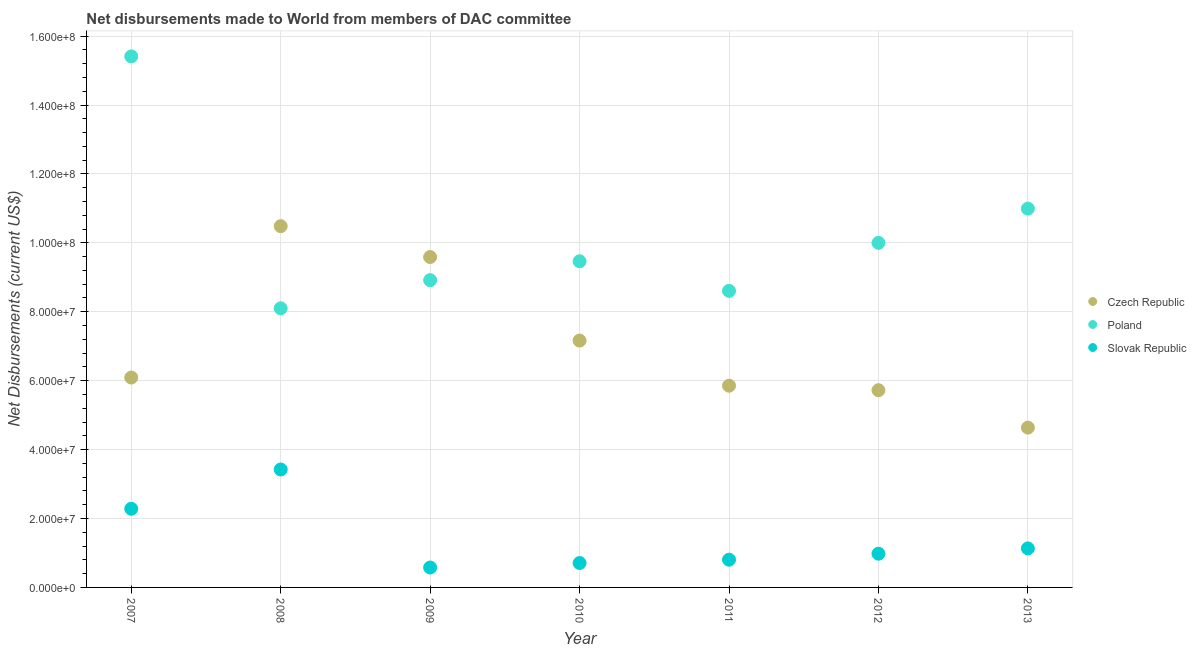How many different coloured dotlines are there?
Your response must be concise. 3. Is the number of dotlines equal to the number of legend labels?
Your answer should be compact. Yes. What is the net disbursements made by slovak republic in 2011?
Offer a terse response. 8.05e+06. Across all years, what is the maximum net disbursements made by slovak republic?
Your answer should be very brief. 3.42e+07. Across all years, what is the minimum net disbursements made by slovak republic?
Give a very brief answer. 5.78e+06. In which year was the net disbursements made by poland maximum?
Give a very brief answer. 2007. What is the total net disbursements made by czech republic in the graph?
Your answer should be compact. 4.95e+08. What is the difference between the net disbursements made by slovak republic in 2012 and that in 2013?
Provide a short and direct response. -1.53e+06. What is the difference between the net disbursements made by czech republic in 2010 and the net disbursements made by slovak republic in 2012?
Your response must be concise. 6.18e+07. What is the average net disbursements made by slovak republic per year?
Keep it short and to the point. 1.42e+07. In the year 2007, what is the difference between the net disbursements made by poland and net disbursements made by czech republic?
Give a very brief answer. 9.32e+07. What is the ratio of the net disbursements made by slovak republic in 2007 to that in 2009?
Your response must be concise. 3.95. Is the net disbursements made by slovak republic in 2008 less than that in 2009?
Make the answer very short. No. What is the difference between the highest and the second highest net disbursements made by czech republic?
Ensure brevity in your answer.  8.96e+06. What is the difference between the highest and the lowest net disbursements made by slovak republic?
Your answer should be compact. 2.84e+07. Is it the case that in every year, the sum of the net disbursements made by czech republic and net disbursements made by poland is greater than the net disbursements made by slovak republic?
Make the answer very short. Yes. Does the net disbursements made by czech republic monotonically increase over the years?
Make the answer very short. No. How many dotlines are there?
Your answer should be compact. 3. How many years are there in the graph?
Offer a terse response. 7. What is the title of the graph?
Provide a short and direct response. Net disbursements made to World from members of DAC committee. Does "Ores and metals" appear as one of the legend labels in the graph?
Make the answer very short. No. What is the label or title of the Y-axis?
Provide a succinct answer. Net Disbursements (current US$). What is the Net Disbursements (current US$) of Czech Republic in 2007?
Offer a terse response. 6.09e+07. What is the Net Disbursements (current US$) in Poland in 2007?
Give a very brief answer. 1.54e+08. What is the Net Disbursements (current US$) of Slovak Republic in 2007?
Your response must be concise. 2.28e+07. What is the Net Disbursements (current US$) of Czech Republic in 2008?
Provide a short and direct response. 1.05e+08. What is the Net Disbursements (current US$) in Poland in 2008?
Offer a very short reply. 8.10e+07. What is the Net Disbursements (current US$) of Slovak Republic in 2008?
Keep it short and to the point. 3.42e+07. What is the Net Disbursements (current US$) of Czech Republic in 2009?
Offer a very short reply. 9.59e+07. What is the Net Disbursements (current US$) of Poland in 2009?
Ensure brevity in your answer.  8.92e+07. What is the Net Disbursements (current US$) of Slovak Republic in 2009?
Offer a very short reply. 5.78e+06. What is the Net Disbursements (current US$) in Czech Republic in 2010?
Provide a succinct answer. 7.16e+07. What is the Net Disbursements (current US$) in Poland in 2010?
Your answer should be very brief. 9.46e+07. What is the Net Disbursements (current US$) of Slovak Republic in 2010?
Make the answer very short. 7.08e+06. What is the Net Disbursements (current US$) in Czech Republic in 2011?
Provide a succinct answer. 5.85e+07. What is the Net Disbursements (current US$) in Poland in 2011?
Offer a terse response. 8.61e+07. What is the Net Disbursements (current US$) of Slovak Republic in 2011?
Provide a succinct answer. 8.05e+06. What is the Net Disbursements (current US$) of Czech Republic in 2012?
Offer a terse response. 5.72e+07. What is the Net Disbursements (current US$) of Poland in 2012?
Keep it short and to the point. 1.00e+08. What is the Net Disbursements (current US$) in Slovak Republic in 2012?
Provide a short and direct response. 9.79e+06. What is the Net Disbursements (current US$) of Czech Republic in 2013?
Offer a very short reply. 4.64e+07. What is the Net Disbursements (current US$) in Poland in 2013?
Your answer should be compact. 1.10e+08. What is the Net Disbursements (current US$) of Slovak Republic in 2013?
Your answer should be very brief. 1.13e+07. Across all years, what is the maximum Net Disbursements (current US$) of Czech Republic?
Give a very brief answer. 1.05e+08. Across all years, what is the maximum Net Disbursements (current US$) of Poland?
Give a very brief answer. 1.54e+08. Across all years, what is the maximum Net Disbursements (current US$) in Slovak Republic?
Ensure brevity in your answer.  3.42e+07. Across all years, what is the minimum Net Disbursements (current US$) in Czech Republic?
Your answer should be very brief. 4.64e+07. Across all years, what is the minimum Net Disbursements (current US$) in Poland?
Keep it short and to the point. 8.10e+07. Across all years, what is the minimum Net Disbursements (current US$) of Slovak Republic?
Provide a succinct answer. 5.78e+06. What is the total Net Disbursements (current US$) of Czech Republic in the graph?
Keep it short and to the point. 4.95e+08. What is the total Net Disbursements (current US$) in Poland in the graph?
Offer a very short reply. 7.15e+08. What is the total Net Disbursements (current US$) of Slovak Republic in the graph?
Your response must be concise. 9.91e+07. What is the difference between the Net Disbursements (current US$) of Czech Republic in 2007 and that in 2008?
Provide a short and direct response. -4.39e+07. What is the difference between the Net Disbursements (current US$) in Poland in 2007 and that in 2008?
Ensure brevity in your answer.  7.31e+07. What is the difference between the Net Disbursements (current US$) of Slovak Republic in 2007 and that in 2008?
Make the answer very short. -1.14e+07. What is the difference between the Net Disbursements (current US$) in Czech Republic in 2007 and that in 2009?
Ensure brevity in your answer.  -3.50e+07. What is the difference between the Net Disbursements (current US$) in Poland in 2007 and that in 2009?
Provide a short and direct response. 6.49e+07. What is the difference between the Net Disbursements (current US$) in Slovak Republic in 2007 and that in 2009?
Provide a succinct answer. 1.70e+07. What is the difference between the Net Disbursements (current US$) of Czech Republic in 2007 and that in 2010?
Keep it short and to the point. -1.07e+07. What is the difference between the Net Disbursements (current US$) of Poland in 2007 and that in 2010?
Offer a terse response. 5.95e+07. What is the difference between the Net Disbursements (current US$) in Slovak Republic in 2007 and that in 2010?
Keep it short and to the point. 1.58e+07. What is the difference between the Net Disbursements (current US$) in Czech Republic in 2007 and that in 2011?
Make the answer very short. 2.37e+06. What is the difference between the Net Disbursements (current US$) of Poland in 2007 and that in 2011?
Give a very brief answer. 6.80e+07. What is the difference between the Net Disbursements (current US$) of Slovak Republic in 2007 and that in 2011?
Keep it short and to the point. 1.48e+07. What is the difference between the Net Disbursements (current US$) in Czech Republic in 2007 and that in 2012?
Provide a short and direct response. 3.67e+06. What is the difference between the Net Disbursements (current US$) of Poland in 2007 and that in 2012?
Give a very brief answer. 5.41e+07. What is the difference between the Net Disbursements (current US$) in Slovak Republic in 2007 and that in 2012?
Offer a terse response. 1.30e+07. What is the difference between the Net Disbursements (current US$) of Czech Republic in 2007 and that in 2013?
Offer a very short reply. 1.45e+07. What is the difference between the Net Disbursements (current US$) in Poland in 2007 and that in 2013?
Give a very brief answer. 4.42e+07. What is the difference between the Net Disbursements (current US$) in Slovak Republic in 2007 and that in 2013?
Provide a short and direct response. 1.15e+07. What is the difference between the Net Disbursements (current US$) in Czech Republic in 2008 and that in 2009?
Your answer should be very brief. 8.96e+06. What is the difference between the Net Disbursements (current US$) in Poland in 2008 and that in 2009?
Your answer should be compact. -8.17e+06. What is the difference between the Net Disbursements (current US$) in Slovak Republic in 2008 and that in 2009?
Your answer should be very brief. 2.84e+07. What is the difference between the Net Disbursements (current US$) in Czech Republic in 2008 and that in 2010?
Keep it short and to the point. 3.32e+07. What is the difference between the Net Disbursements (current US$) in Poland in 2008 and that in 2010?
Your response must be concise. -1.36e+07. What is the difference between the Net Disbursements (current US$) in Slovak Republic in 2008 and that in 2010?
Offer a terse response. 2.72e+07. What is the difference between the Net Disbursements (current US$) in Czech Republic in 2008 and that in 2011?
Give a very brief answer. 4.63e+07. What is the difference between the Net Disbursements (current US$) of Poland in 2008 and that in 2011?
Your answer should be very brief. -5.07e+06. What is the difference between the Net Disbursements (current US$) in Slovak Republic in 2008 and that in 2011?
Provide a succinct answer. 2.62e+07. What is the difference between the Net Disbursements (current US$) of Czech Republic in 2008 and that in 2012?
Make the answer very short. 4.76e+07. What is the difference between the Net Disbursements (current US$) in Poland in 2008 and that in 2012?
Ensure brevity in your answer.  -1.90e+07. What is the difference between the Net Disbursements (current US$) of Slovak Republic in 2008 and that in 2012?
Your answer should be very brief. 2.44e+07. What is the difference between the Net Disbursements (current US$) of Czech Republic in 2008 and that in 2013?
Your answer should be very brief. 5.85e+07. What is the difference between the Net Disbursements (current US$) in Poland in 2008 and that in 2013?
Your response must be concise. -2.89e+07. What is the difference between the Net Disbursements (current US$) in Slovak Republic in 2008 and that in 2013?
Ensure brevity in your answer.  2.29e+07. What is the difference between the Net Disbursements (current US$) in Czech Republic in 2009 and that in 2010?
Ensure brevity in your answer.  2.42e+07. What is the difference between the Net Disbursements (current US$) in Poland in 2009 and that in 2010?
Ensure brevity in your answer.  -5.48e+06. What is the difference between the Net Disbursements (current US$) in Slovak Republic in 2009 and that in 2010?
Provide a succinct answer. -1.30e+06. What is the difference between the Net Disbursements (current US$) of Czech Republic in 2009 and that in 2011?
Your answer should be compact. 3.73e+07. What is the difference between the Net Disbursements (current US$) in Poland in 2009 and that in 2011?
Provide a short and direct response. 3.10e+06. What is the difference between the Net Disbursements (current US$) in Slovak Republic in 2009 and that in 2011?
Your answer should be compact. -2.27e+06. What is the difference between the Net Disbursements (current US$) in Czech Republic in 2009 and that in 2012?
Keep it short and to the point. 3.86e+07. What is the difference between the Net Disbursements (current US$) of Poland in 2009 and that in 2012?
Make the answer very short. -1.08e+07. What is the difference between the Net Disbursements (current US$) of Slovak Republic in 2009 and that in 2012?
Ensure brevity in your answer.  -4.01e+06. What is the difference between the Net Disbursements (current US$) in Czech Republic in 2009 and that in 2013?
Give a very brief answer. 4.95e+07. What is the difference between the Net Disbursements (current US$) in Poland in 2009 and that in 2013?
Give a very brief answer. -2.08e+07. What is the difference between the Net Disbursements (current US$) in Slovak Republic in 2009 and that in 2013?
Your response must be concise. -5.54e+06. What is the difference between the Net Disbursements (current US$) in Czech Republic in 2010 and that in 2011?
Your response must be concise. 1.31e+07. What is the difference between the Net Disbursements (current US$) of Poland in 2010 and that in 2011?
Ensure brevity in your answer.  8.58e+06. What is the difference between the Net Disbursements (current US$) in Slovak Republic in 2010 and that in 2011?
Provide a short and direct response. -9.70e+05. What is the difference between the Net Disbursements (current US$) in Czech Republic in 2010 and that in 2012?
Provide a short and direct response. 1.44e+07. What is the difference between the Net Disbursements (current US$) in Poland in 2010 and that in 2012?
Make the answer very short. -5.34e+06. What is the difference between the Net Disbursements (current US$) in Slovak Republic in 2010 and that in 2012?
Provide a short and direct response. -2.71e+06. What is the difference between the Net Disbursements (current US$) in Czech Republic in 2010 and that in 2013?
Offer a very short reply. 2.53e+07. What is the difference between the Net Disbursements (current US$) of Poland in 2010 and that in 2013?
Ensure brevity in your answer.  -1.53e+07. What is the difference between the Net Disbursements (current US$) in Slovak Republic in 2010 and that in 2013?
Your response must be concise. -4.24e+06. What is the difference between the Net Disbursements (current US$) in Czech Republic in 2011 and that in 2012?
Your answer should be compact. 1.30e+06. What is the difference between the Net Disbursements (current US$) of Poland in 2011 and that in 2012?
Make the answer very short. -1.39e+07. What is the difference between the Net Disbursements (current US$) of Slovak Republic in 2011 and that in 2012?
Your answer should be compact. -1.74e+06. What is the difference between the Net Disbursements (current US$) in Czech Republic in 2011 and that in 2013?
Make the answer very short. 1.22e+07. What is the difference between the Net Disbursements (current US$) of Poland in 2011 and that in 2013?
Provide a succinct answer. -2.39e+07. What is the difference between the Net Disbursements (current US$) in Slovak Republic in 2011 and that in 2013?
Your answer should be compact. -3.27e+06. What is the difference between the Net Disbursements (current US$) in Czech Republic in 2012 and that in 2013?
Your answer should be very brief. 1.09e+07. What is the difference between the Net Disbursements (current US$) of Poland in 2012 and that in 2013?
Provide a succinct answer. -9.94e+06. What is the difference between the Net Disbursements (current US$) in Slovak Republic in 2012 and that in 2013?
Your answer should be very brief. -1.53e+06. What is the difference between the Net Disbursements (current US$) in Czech Republic in 2007 and the Net Disbursements (current US$) in Poland in 2008?
Give a very brief answer. -2.01e+07. What is the difference between the Net Disbursements (current US$) of Czech Republic in 2007 and the Net Disbursements (current US$) of Slovak Republic in 2008?
Make the answer very short. 2.67e+07. What is the difference between the Net Disbursements (current US$) of Poland in 2007 and the Net Disbursements (current US$) of Slovak Republic in 2008?
Offer a very short reply. 1.20e+08. What is the difference between the Net Disbursements (current US$) of Czech Republic in 2007 and the Net Disbursements (current US$) of Poland in 2009?
Make the answer very short. -2.83e+07. What is the difference between the Net Disbursements (current US$) of Czech Republic in 2007 and the Net Disbursements (current US$) of Slovak Republic in 2009?
Your answer should be very brief. 5.51e+07. What is the difference between the Net Disbursements (current US$) of Poland in 2007 and the Net Disbursements (current US$) of Slovak Republic in 2009?
Ensure brevity in your answer.  1.48e+08. What is the difference between the Net Disbursements (current US$) of Czech Republic in 2007 and the Net Disbursements (current US$) of Poland in 2010?
Give a very brief answer. -3.37e+07. What is the difference between the Net Disbursements (current US$) of Czech Republic in 2007 and the Net Disbursements (current US$) of Slovak Republic in 2010?
Your answer should be very brief. 5.38e+07. What is the difference between the Net Disbursements (current US$) of Poland in 2007 and the Net Disbursements (current US$) of Slovak Republic in 2010?
Give a very brief answer. 1.47e+08. What is the difference between the Net Disbursements (current US$) of Czech Republic in 2007 and the Net Disbursements (current US$) of Poland in 2011?
Ensure brevity in your answer.  -2.52e+07. What is the difference between the Net Disbursements (current US$) of Czech Republic in 2007 and the Net Disbursements (current US$) of Slovak Republic in 2011?
Ensure brevity in your answer.  5.29e+07. What is the difference between the Net Disbursements (current US$) in Poland in 2007 and the Net Disbursements (current US$) in Slovak Republic in 2011?
Your answer should be compact. 1.46e+08. What is the difference between the Net Disbursements (current US$) in Czech Republic in 2007 and the Net Disbursements (current US$) in Poland in 2012?
Provide a succinct answer. -3.91e+07. What is the difference between the Net Disbursements (current US$) of Czech Republic in 2007 and the Net Disbursements (current US$) of Slovak Republic in 2012?
Offer a terse response. 5.11e+07. What is the difference between the Net Disbursements (current US$) in Poland in 2007 and the Net Disbursements (current US$) in Slovak Republic in 2012?
Ensure brevity in your answer.  1.44e+08. What is the difference between the Net Disbursements (current US$) in Czech Republic in 2007 and the Net Disbursements (current US$) in Poland in 2013?
Give a very brief answer. -4.90e+07. What is the difference between the Net Disbursements (current US$) in Czech Republic in 2007 and the Net Disbursements (current US$) in Slovak Republic in 2013?
Offer a terse response. 4.96e+07. What is the difference between the Net Disbursements (current US$) of Poland in 2007 and the Net Disbursements (current US$) of Slovak Republic in 2013?
Give a very brief answer. 1.43e+08. What is the difference between the Net Disbursements (current US$) of Czech Republic in 2008 and the Net Disbursements (current US$) of Poland in 2009?
Your response must be concise. 1.57e+07. What is the difference between the Net Disbursements (current US$) of Czech Republic in 2008 and the Net Disbursements (current US$) of Slovak Republic in 2009?
Keep it short and to the point. 9.91e+07. What is the difference between the Net Disbursements (current US$) of Poland in 2008 and the Net Disbursements (current US$) of Slovak Republic in 2009?
Make the answer very short. 7.52e+07. What is the difference between the Net Disbursements (current US$) of Czech Republic in 2008 and the Net Disbursements (current US$) of Poland in 2010?
Provide a short and direct response. 1.02e+07. What is the difference between the Net Disbursements (current US$) of Czech Republic in 2008 and the Net Disbursements (current US$) of Slovak Republic in 2010?
Offer a terse response. 9.78e+07. What is the difference between the Net Disbursements (current US$) in Poland in 2008 and the Net Disbursements (current US$) in Slovak Republic in 2010?
Your response must be concise. 7.39e+07. What is the difference between the Net Disbursements (current US$) in Czech Republic in 2008 and the Net Disbursements (current US$) in Poland in 2011?
Your response must be concise. 1.88e+07. What is the difference between the Net Disbursements (current US$) of Czech Republic in 2008 and the Net Disbursements (current US$) of Slovak Republic in 2011?
Keep it short and to the point. 9.68e+07. What is the difference between the Net Disbursements (current US$) of Poland in 2008 and the Net Disbursements (current US$) of Slovak Republic in 2011?
Make the answer very short. 7.30e+07. What is the difference between the Net Disbursements (current US$) of Czech Republic in 2008 and the Net Disbursements (current US$) of Poland in 2012?
Your answer should be compact. 4.85e+06. What is the difference between the Net Disbursements (current US$) in Czech Republic in 2008 and the Net Disbursements (current US$) in Slovak Republic in 2012?
Your answer should be compact. 9.50e+07. What is the difference between the Net Disbursements (current US$) of Poland in 2008 and the Net Disbursements (current US$) of Slovak Republic in 2012?
Provide a succinct answer. 7.12e+07. What is the difference between the Net Disbursements (current US$) of Czech Republic in 2008 and the Net Disbursements (current US$) of Poland in 2013?
Your answer should be very brief. -5.09e+06. What is the difference between the Net Disbursements (current US$) in Czech Republic in 2008 and the Net Disbursements (current US$) in Slovak Republic in 2013?
Offer a very short reply. 9.35e+07. What is the difference between the Net Disbursements (current US$) of Poland in 2008 and the Net Disbursements (current US$) of Slovak Republic in 2013?
Give a very brief answer. 6.97e+07. What is the difference between the Net Disbursements (current US$) in Czech Republic in 2009 and the Net Disbursements (current US$) in Poland in 2010?
Keep it short and to the point. 1.23e+06. What is the difference between the Net Disbursements (current US$) in Czech Republic in 2009 and the Net Disbursements (current US$) in Slovak Republic in 2010?
Provide a short and direct response. 8.88e+07. What is the difference between the Net Disbursements (current US$) in Poland in 2009 and the Net Disbursements (current US$) in Slovak Republic in 2010?
Give a very brief answer. 8.21e+07. What is the difference between the Net Disbursements (current US$) in Czech Republic in 2009 and the Net Disbursements (current US$) in Poland in 2011?
Provide a short and direct response. 9.81e+06. What is the difference between the Net Disbursements (current US$) of Czech Republic in 2009 and the Net Disbursements (current US$) of Slovak Republic in 2011?
Ensure brevity in your answer.  8.78e+07. What is the difference between the Net Disbursements (current US$) of Poland in 2009 and the Net Disbursements (current US$) of Slovak Republic in 2011?
Ensure brevity in your answer.  8.11e+07. What is the difference between the Net Disbursements (current US$) of Czech Republic in 2009 and the Net Disbursements (current US$) of Poland in 2012?
Offer a very short reply. -4.11e+06. What is the difference between the Net Disbursements (current US$) of Czech Republic in 2009 and the Net Disbursements (current US$) of Slovak Republic in 2012?
Make the answer very short. 8.61e+07. What is the difference between the Net Disbursements (current US$) in Poland in 2009 and the Net Disbursements (current US$) in Slovak Republic in 2012?
Provide a short and direct response. 7.94e+07. What is the difference between the Net Disbursements (current US$) in Czech Republic in 2009 and the Net Disbursements (current US$) in Poland in 2013?
Provide a succinct answer. -1.40e+07. What is the difference between the Net Disbursements (current US$) of Czech Republic in 2009 and the Net Disbursements (current US$) of Slovak Republic in 2013?
Give a very brief answer. 8.46e+07. What is the difference between the Net Disbursements (current US$) in Poland in 2009 and the Net Disbursements (current US$) in Slovak Republic in 2013?
Your answer should be compact. 7.78e+07. What is the difference between the Net Disbursements (current US$) in Czech Republic in 2010 and the Net Disbursements (current US$) in Poland in 2011?
Provide a succinct answer. -1.44e+07. What is the difference between the Net Disbursements (current US$) of Czech Republic in 2010 and the Net Disbursements (current US$) of Slovak Republic in 2011?
Offer a very short reply. 6.36e+07. What is the difference between the Net Disbursements (current US$) of Poland in 2010 and the Net Disbursements (current US$) of Slovak Republic in 2011?
Offer a terse response. 8.66e+07. What is the difference between the Net Disbursements (current US$) in Czech Republic in 2010 and the Net Disbursements (current US$) in Poland in 2012?
Keep it short and to the point. -2.84e+07. What is the difference between the Net Disbursements (current US$) of Czech Republic in 2010 and the Net Disbursements (current US$) of Slovak Republic in 2012?
Your answer should be compact. 6.18e+07. What is the difference between the Net Disbursements (current US$) of Poland in 2010 and the Net Disbursements (current US$) of Slovak Republic in 2012?
Your answer should be very brief. 8.49e+07. What is the difference between the Net Disbursements (current US$) of Czech Republic in 2010 and the Net Disbursements (current US$) of Poland in 2013?
Keep it short and to the point. -3.83e+07. What is the difference between the Net Disbursements (current US$) in Czech Republic in 2010 and the Net Disbursements (current US$) in Slovak Republic in 2013?
Provide a short and direct response. 6.03e+07. What is the difference between the Net Disbursements (current US$) in Poland in 2010 and the Net Disbursements (current US$) in Slovak Republic in 2013?
Offer a terse response. 8.33e+07. What is the difference between the Net Disbursements (current US$) of Czech Republic in 2011 and the Net Disbursements (current US$) of Poland in 2012?
Your response must be concise. -4.14e+07. What is the difference between the Net Disbursements (current US$) in Czech Republic in 2011 and the Net Disbursements (current US$) in Slovak Republic in 2012?
Make the answer very short. 4.88e+07. What is the difference between the Net Disbursements (current US$) of Poland in 2011 and the Net Disbursements (current US$) of Slovak Republic in 2012?
Keep it short and to the point. 7.63e+07. What is the difference between the Net Disbursements (current US$) in Czech Republic in 2011 and the Net Disbursements (current US$) in Poland in 2013?
Give a very brief answer. -5.14e+07. What is the difference between the Net Disbursements (current US$) in Czech Republic in 2011 and the Net Disbursements (current US$) in Slovak Republic in 2013?
Give a very brief answer. 4.72e+07. What is the difference between the Net Disbursements (current US$) of Poland in 2011 and the Net Disbursements (current US$) of Slovak Republic in 2013?
Ensure brevity in your answer.  7.48e+07. What is the difference between the Net Disbursements (current US$) of Czech Republic in 2012 and the Net Disbursements (current US$) of Poland in 2013?
Provide a short and direct response. -5.27e+07. What is the difference between the Net Disbursements (current US$) of Czech Republic in 2012 and the Net Disbursements (current US$) of Slovak Republic in 2013?
Provide a succinct answer. 4.59e+07. What is the difference between the Net Disbursements (current US$) of Poland in 2012 and the Net Disbursements (current US$) of Slovak Republic in 2013?
Offer a terse response. 8.87e+07. What is the average Net Disbursements (current US$) of Czech Republic per year?
Make the answer very short. 7.08e+07. What is the average Net Disbursements (current US$) in Poland per year?
Provide a succinct answer. 1.02e+08. What is the average Net Disbursements (current US$) in Slovak Republic per year?
Ensure brevity in your answer.  1.42e+07. In the year 2007, what is the difference between the Net Disbursements (current US$) of Czech Republic and Net Disbursements (current US$) of Poland?
Your answer should be compact. -9.32e+07. In the year 2007, what is the difference between the Net Disbursements (current US$) in Czech Republic and Net Disbursements (current US$) in Slovak Republic?
Your answer should be compact. 3.81e+07. In the year 2007, what is the difference between the Net Disbursements (current US$) of Poland and Net Disbursements (current US$) of Slovak Republic?
Your answer should be compact. 1.31e+08. In the year 2008, what is the difference between the Net Disbursements (current US$) in Czech Republic and Net Disbursements (current US$) in Poland?
Provide a short and direct response. 2.38e+07. In the year 2008, what is the difference between the Net Disbursements (current US$) in Czech Republic and Net Disbursements (current US$) in Slovak Republic?
Keep it short and to the point. 7.06e+07. In the year 2008, what is the difference between the Net Disbursements (current US$) in Poland and Net Disbursements (current US$) in Slovak Republic?
Offer a very short reply. 4.68e+07. In the year 2009, what is the difference between the Net Disbursements (current US$) of Czech Republic and Net Disbursements (current US$) of Poland?
Your answer should be compact. 6.71e+06. In the year 2009, what is the difference between the Net Disbursements (current US$) of Czech Republic and Net Disbursements (current US$) of Slovak Republic?
Your answer should be very brief. 9.01e+07. In the year 2009, what is the difference between the Net Disbursements (current US$) in Poland and Net Disbursements (current US$) in Slovak Republic?
Offer a terse response. 8.34e+07. In the year 2010, what is the difference between the Net Disbursements (current US$) of Czech Republic and Net Disbursements (current US$) of Poland?
Provide a succinct answer. -2.30e+07. In the year 2010, what is the difference between the Net Disbursements (current US$) in Czech Republic and Net Disbursements (current US$) in Slovak Republic?
Provide a succinct answer. 6.46e+07. In the year 2010, what is the difference between the Net Disbursements (current US$) of Poland and Net Disbursements (current US$) of Slovak Republic?
Give a very brief answer. 8.76e+07. In the year 2011, what is the difference between the Net Disbursements (current US$) in Czech Republic and Net Disbursements (current US$) in Poland?
Your answer should be compact. -2.75e+07. In the year 2011, what is the difference between the Net Disbursements (current US$) in Czech Republic and Net Disbursements (current US$) in Slovak Republic?
Keep it short and to the point. 5.05e+07. In the year 2011, what is the difference between the Net Disbursements (current US$) of Poland and Net Disbursements (current US$) of Slovak Republic?
Your answer should be compact. 7.80e+07. In the year 2012, what is the difference between the Net Disbursements (current US$) in Czech Republic and Net Disbursements (current US$) in Poland?
Offer a terse response. -4.28e+07. In the year 2012, what is the difference between the Net Disbursements (current US$) of Czech Republic and Net Disbursements (current US$) of Slovak Republic?
Provide a short and direct response. 4.74e+07. In the year 2012, what is the difference between the Net Disbursements (current US$) in Poland and Net Disbursements (current US$) in Slovak Republic?
Ensure brevity in your answer.  9.02e+07. In the year 2013, what is the difference between the Net Disbursements (current US$) in Czech Republic and Net Disbursements (current US$) in Poland?
Offer a very short reply. -6.36e+07. In the year 2013, what is the difference between the Net Disbursements (current US$) of Czech Republic and Net Disbursements (current US$) of Slovak Republic?
Your answer should be compact. 3.51e+07. In the year 2013, what is the difference between the Net Disbursements (current US$) in Poland and Net Disbursements (current US$) in Slovak Republic?
Keep it short and to the point. 9.86e+07. What is the ratio of the Net Disbursements (current US$) of Czech Republic in 2007 to that in 2008?
Your answer should be compact. 0.58. What is the ratio of the Net Disbursements (current US$) in Poland in 2007 to that in 2008?
Give a very brief answer. 1.9. What is the ratio of the Net Disbursements (current US$) of Slovak Republic in 2007 to that in 2008?
Offer a terse response. 0.67. What is the ratio of the Net Disbursements (current US$) in Czech Republic in 2007 to that in 2009?
Make the answer very short. 0.64. What is the ratio of the Net Disbursements (current US$) of Poland in 2007 to that in 2009?
Ensure brevity in your answer.  1.73. What is the ratio of the Net Disbursements (current US$) in Slovak Republic in 2007 to that in 2009?
Make the answer very short. 3.95. What is the ratio of the Net Disbursements (current US$) in Czech Republic in 2007 to that in 2010?
Make the answer very short. 0.85. What is the ratio of the Net Disbursements (current US$) in Poland in 2007 to that in 2010?
Give a very brief answer. 1.63. What is the ratio of the Net Disbursements (current US$) of Slovak Republic in 2007 to that in 2010?
Your answer should be very brief. 3.22. What is the ratio of the Net Disbursements (current US$) of Czech Republic in 2007 to that in 2011?
Offer a very short reply. 1.04. What is the ratio of the Net Disbursements (current US$) of Poland in 2007 to that in 2011?
Keep it short and to the point. 1.79. What is the ratio of the Net Disbursements (current US$) in Slovak Republic in 2007 to that in 2011?
Your answer should be compact. 2.84. What is the ratio of the Net Disbursements (current US$) of Czech Republic in 2007 to that in 2012?
Provide a succinct answer. 1.06. What is the ratio of the Net Disbursements (current US$) of Poland in 2007 to that in 2012?
Provide a succinct answer. 1.54. What is the ratio of the Net Disbursements (current US$) in Slovak Republic in 2007 to that in 2012?
Provide a short and direct response. 2.33. What is the ratio of the Net Disbursements (current US$) of Czech Republic in 2007 to that in 2013?
Provide a short and direct response. 1.31. What is the ratio of the Net Disbursements (current US$) in Poland in 2007 to that in 2013?
Make the answer very short. 1.4. What is the ratio of the Net Disbursements (current US$) in Slovak Republic in 2007 to that in 2013?
Your answer should be very brief. 2.02. What is the ratio of the Net Disbursements (current US$) of Czech Republic in 2008 to that in 2009?
Your answer should be very brief. 1.09. What is the ratio of the Net Disbursements (current US$) in Poland in 2008 to that in 2009?
Provide a succinct answer. 0.91. What is the ratio of the Net Disbursements (current US$) in Slovak Republic in 2008 to that in 2009?
Make the answer very short. 5.92. What is the ratio of the Net Disbursements (current US$) in Czech Republic in 2008 to that in 2010?
Keep it short and to the point. 1.46. What is the ratio of the Net Disbursements (current US$) in Poland in 2008 to that in 2010?
Provide a succinct answer. 0.86. What is the ratio of the Net Disbursements (current US$) in Slovak Republic in 2008 to that in 2010?
Your response must be concise. 4.83. What is the ratio of the Net Disbursements (current US$) in Czech Republic in 2008 to that in 2011?
Your answer should be compact. 1.79. What is the ratio of the Net Disbursements (current US$) in Poland in 2008 to that in 2011?
Your response must be concise. 0.94. What is the ratio of the Net Disbursements (current US$) in Slovak Republic in 2008 to that in 2011?
Make the answer very short. 4.25. What is the ratio of the Net Disbursements (current US$) of Czech Republic in 2008 to that in 2012?
Keep it short and to the point. 1.83. What is the ratio of the Net Disbursements (current US$) in Poland in 2008 to that in 2012?
Ensure brevity in your answer.  0.81. What is the ratio of the Net Disbursements (current US$) of Slovak Republic in 2008 to that in 2012?
Make the answer very short. 3.5. What is the ratio of the Net Disbursements (current US$) in Czech Republic in 2008 to that in 2013?
Make the answer very short. 2.26. What is the ratio of the Net Disbursements (current US$) in Poland in 2008 to that in 2013?
Your answer should be very brief. 0.74. What is the ratio of the Net Disbursements (current US$) of Slovak Republic in 2008 to that in 2013?
Offer a very short reply. 3.02. What is the ratio of the Net Disbursements (current US$) of Czech Republic in 2009 to that in 2010?
Offer a terse response. 1.34. What is the ratio of the Net Disbursements (current US$) in Poland in 2009 to that in 2010?
Your answer should be very brief. 0.94. What is the ratio of the Net Disbursements (current US$) in Slovak Republic in 2009 to that in 2010?
Provide a succinct answer. 0.82. What is the ratio of the Net Disbursements (current US$) in Czech Republic in 2009 to that in 2011?
Ensure brevity in your answer.  1.64. What is the ratio of the Net Disbursements (current US$) in Poland in 2009 to that in 2011?
Provide a short and direct response. 1.04. What is the ratio of the Net Disbursements (current US$) of Slovak Republic in 2009 to that in 2011?
Keep it short and to the point. 0.72. What is the ratio of the Net Disbursements (current US$) of Czech Republic in 2009 to that in 2012?
Give a very brief answer. 1.68. What is the ratio of the Net Disbursements (current US$) in Poland in 2009 to that in 2012?
Offer a terse response. 0.89. What is the ratio of the Net Disbursements (current US$) in Slovak Republic in 2009 to that in 2012?
Offer a very short reply. 0.59. What is the ratio of the Net Disbursements (current US$) in Czech Republic in 2009 to that in 2013?
Your answer should be very brief. 2.07. What is the ratio of the Net Disbursements (current US$) in Poland in 2009 to that in 2013?
Your answer should be very brief. 0.81. What is the ratio of the Net Disbursements (current US$) of Slovak Republic in 2009 to that in 2013?
Keep it short and to the point. 0.51. What is the ratio of the Net Disbursements (current US$) in Czech Republic in 2010 to that in 2011?
Provide a succinct answer. 1.22. What is the ratio of the Net Disbursements (current US$) in Poland in 2010 to that in 2011?
Provide a short and direct response. 1.1. What is the ratio of the Net Disbursements (current US$) in Slovak Republic in 2010 to that in 2011?
Offer a very short reply. 0.88. What is the ratio of the Net Disbursements (current US$) of Czech Republic in 2010 to that in 2012?
Provide a succinct answer. 1.25. What is the ratio of the Net Disbursements (current US$) in Poland in 2010 to that in 2012?
Make the answer very short. 0.95. What is the ratio of the Net Disbursements (current US$) in Slovak Republic in 2010 to that in 2012?
Keep it short and to the point. 0.72. What is the ratio of the Net Disbursements (current US$) in Czech Republic in 2010 to that in 2013?
Make the answer very short. 1.54. What is the ratio of the Net Disbursements (current US$) in Poland in 2010 to that in 2013?
Provide a short and direct response. 0.86. What is the ratio of the Net Disbursements (current US$) in Slovak Republic in 2010 to that in 2013?
Keep it short and to the point. 0.63. What is the ratio of the Net Disbursements (current US$) in Czech Republic in 2011 to that in 2012?
Offer a very short reply. 1.02. What is the ratio of the Net Disbursements (current US$) of Poland in 2011 to that in 2012?
Ensure brevity in your answer.  0.86. What is the ratio of the Net Disbursements (current US$) in Slovak Republic in 2011 to that in 2012?
Ensure brevity in your answer.  0.82. What is the ratio of the Net Disbursements (current US$) of Czech Republic in 2011 to that in 2013?
Offer a very short reply. 1.26. What is the ratio of the Net Disbursements (current US$) in Poland in 2011 to that in 2013?
Your answer should be compact. 0.78. What is the ratio of the Net Disbursements (current US$) of Slovak Republic in 2011 to that in 2013?
Provide a succinct answer. 0.71. What is the ratio of the Net Disbursements (current US$) of Czech Republic in 2012 to that in 2013?
Offer a terse response. 1.23. What is the ratio of the Net Disbursements (current US$) of Poland in 2012 to that in 2013?
Provide a succinct answer. 0.91. What is the ratio of the Net Disbursements (current US$) of Slovak Republic in 2012 to that in 2013?
Ensure brevity in your answer.  0.86. What is the difference between the highest and the second highest Net Disbursements (current US$) in Czech Republic?
Your response must be concise. 8.96e+06. What is the difference between the highest and the second highest Net Disbursements (current US$) in Poland?
Your response must be concise. 4.42e+07. What is the difference between the highest and the second highest Net Disbursements (current US$) of Slovak Republic?
Ensure brevity in your answer.  1.14e+07. What is the difference between the highest and the lowest Net Disbursements (current US$) in Czech Republic?
Your answer should be compact. 5.85e+07. What is the difference between the highest and the lowest Net Disbursements (current US$) in Poland?
Your response must be concise. 7.31e+07. What is the difference between the highest and the lowest Net Disbursements (current US$) of Slovak Republic?
Provide a short and direct response. 2.84e+07. 